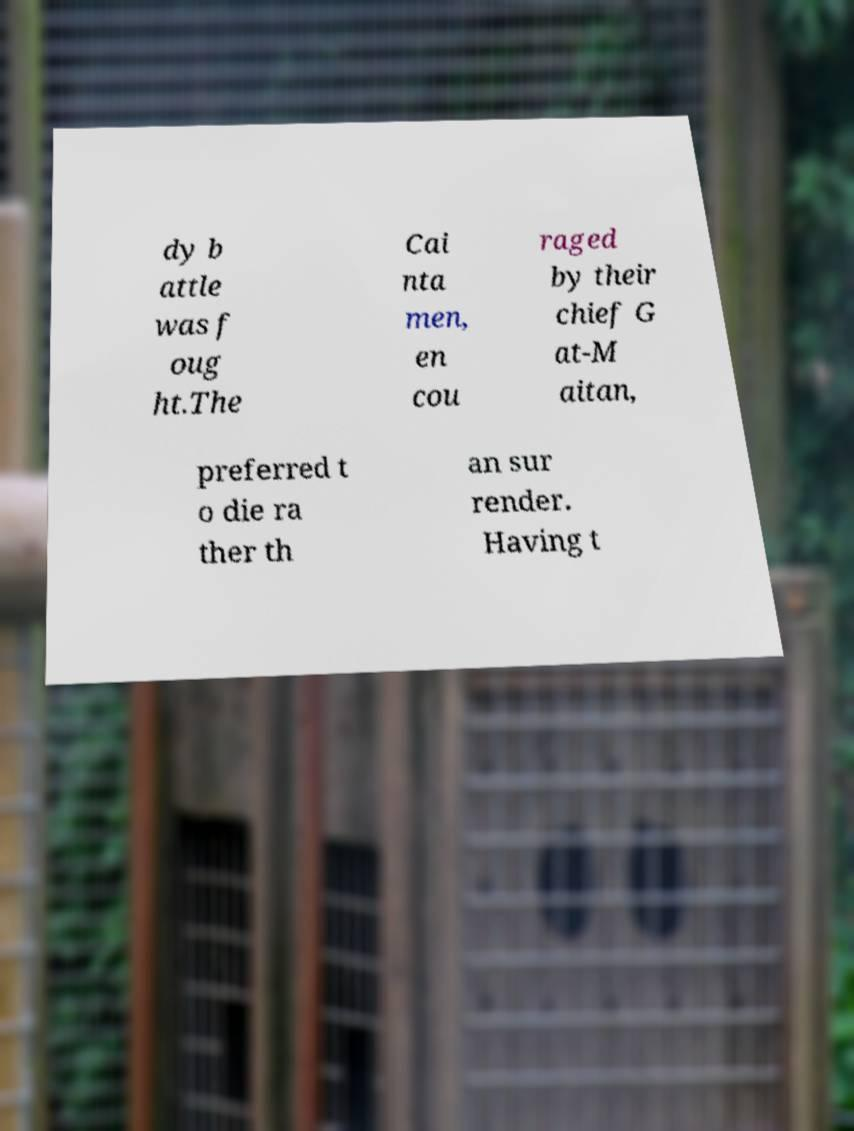For documentation purposes, I need the text within this image transcribed. Could you provide that? dy b attle was f oug ht.The Cai nta men, en cou raged by their chief G at-M aitan, preferred t o die ra ther th an sur render. Having t 